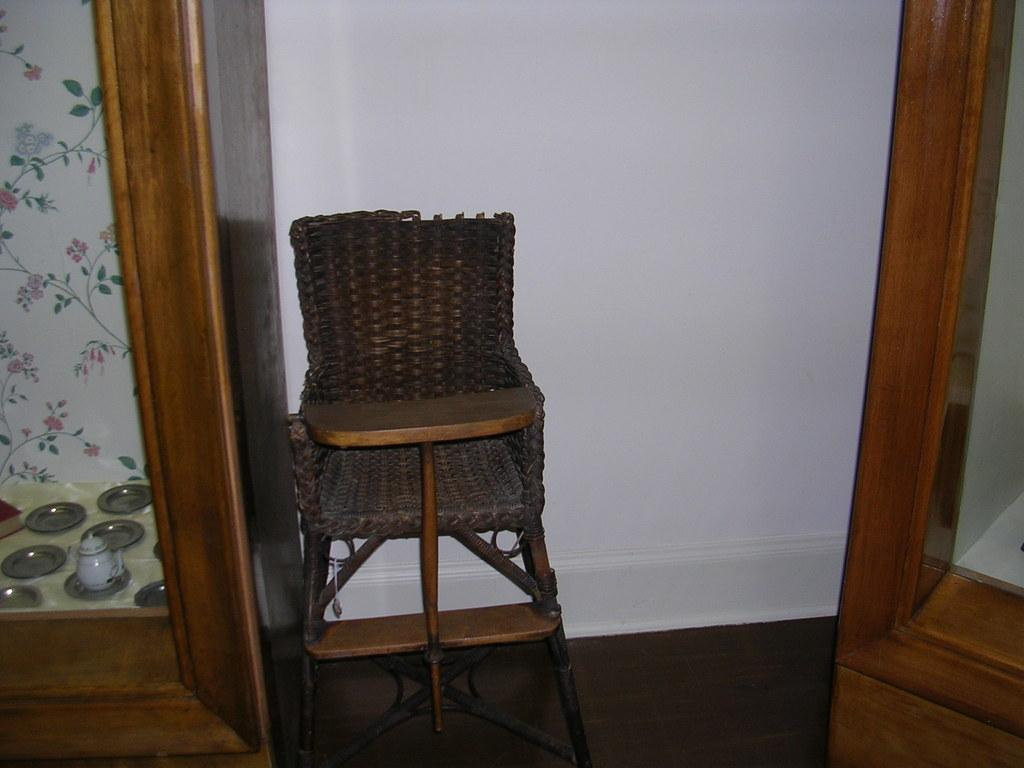What is the main object in the center of the image? There is a chair in the center of the image. What can be seen in the background of the image? There are cupboards and a wall in the background. What items are visible in the image that are used for eating or cooking? There are utensils visible in the image. What surface is the chair and cupboards resting on? There is a floor at the bottom of the image. What is the name of the hill visible in the image? There is no hill visible in the image; it is an indoor setting with a chair, cupboards, utensils, and a floor. 